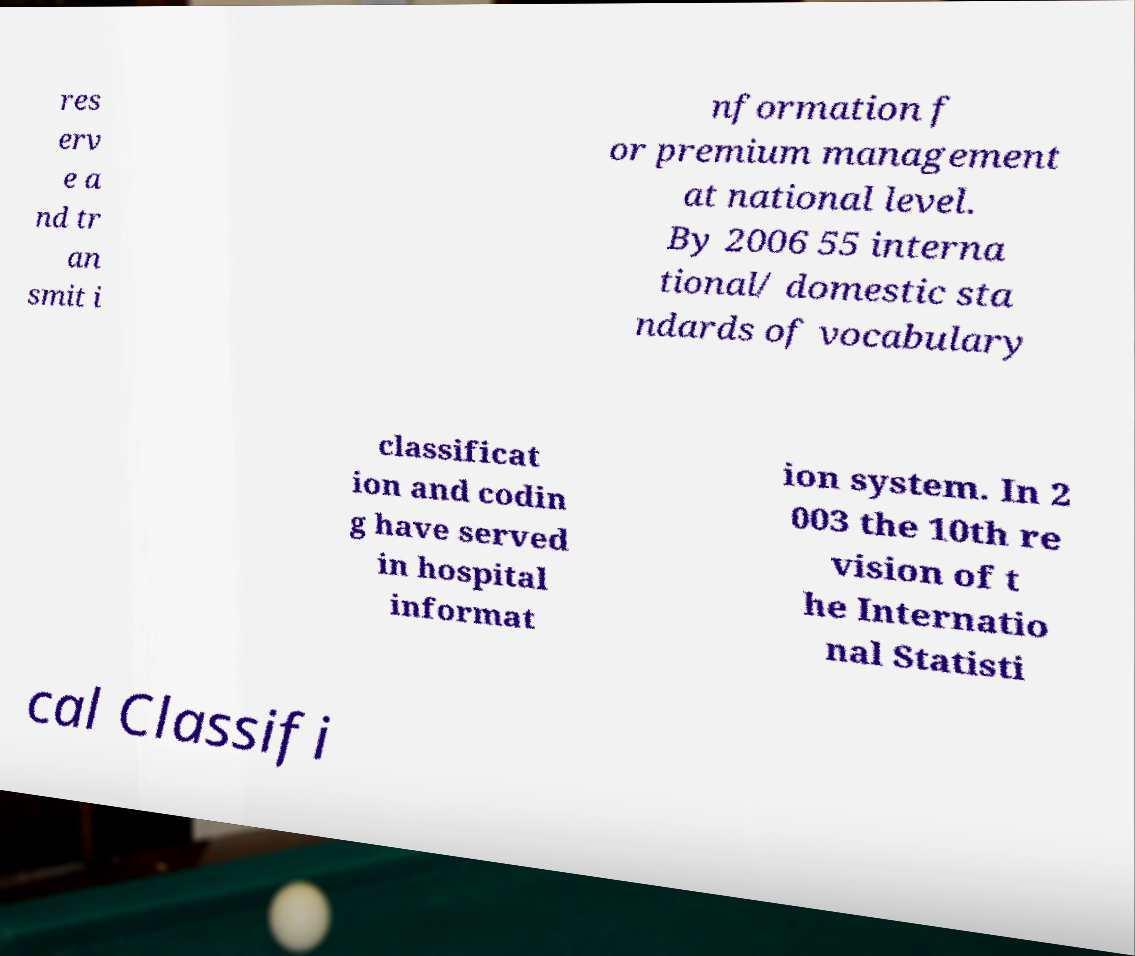Please identify and transcribe the text found in this image. res erv e a nd tr an smit i nformation f or premium management at national level. By 2006 55 interna tional/ domestic sta ndards of vocabulary classificat ion and codin g have served in hospital informat ion system. In 2 003 the 10th re vision of t he Internatio nal Statisti cal Classifi 